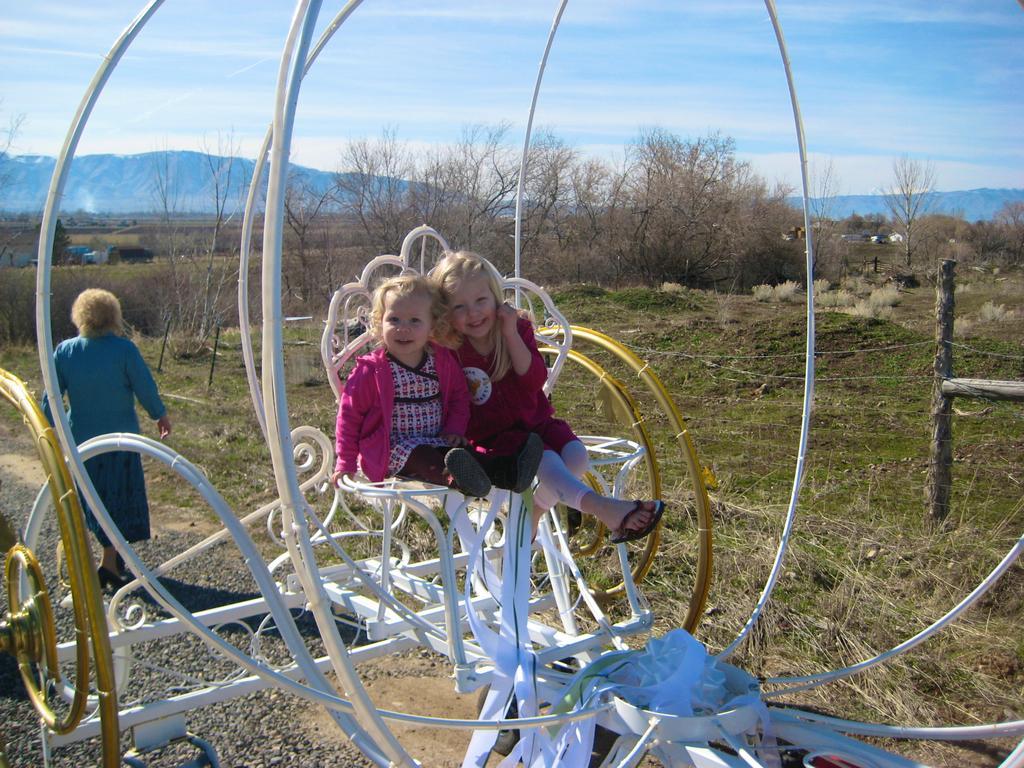Could you give a brief overview of what you see in this image? In this image in the front there is an object which is white in colour and there are kids sitting on the object and there is a woman standing. In the background there are dry trees, there is grass on the ground and the sky is cloudy. 